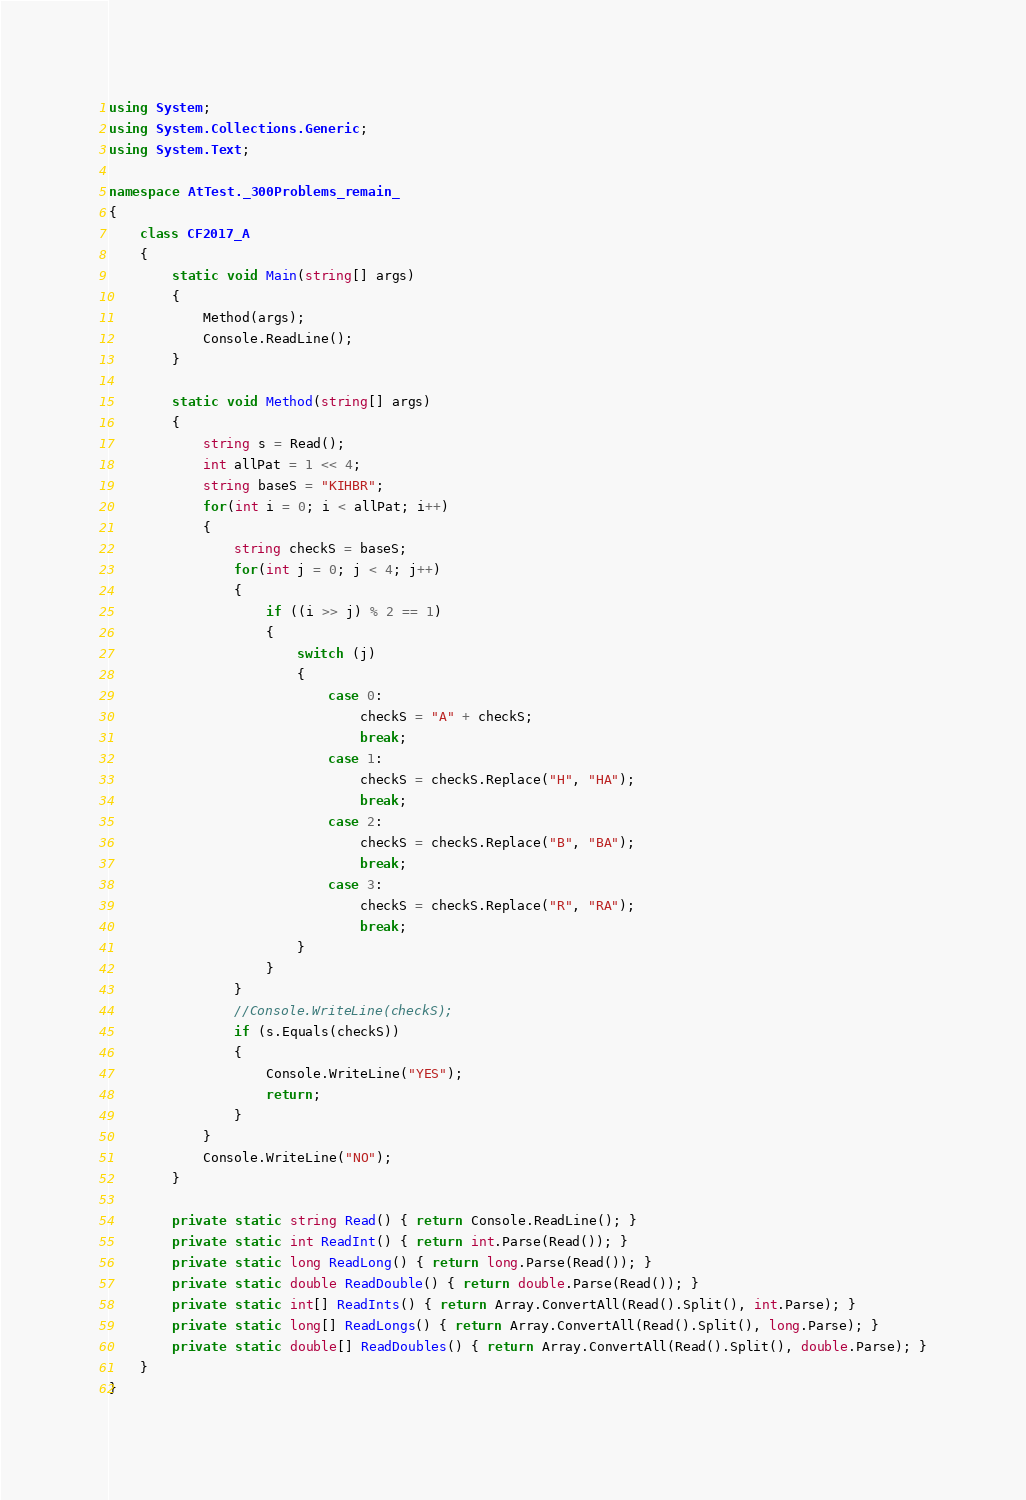<code> <loc_0><loc_0><loc_500><loc_500><_C#_>using System;
using System.Collections.Generic;
using System.Text;

namespace AtTest._300Problems_remain_
{
    class CF2017_A
    {
        static void Main(string[] args)
        {
            Method(args);
            Console.ReadLine();
        }

        static void Method(string[] args)
        {
            string s = Read();
            int allPat = 1 << 4;
            string baseS = "KIHBR";
            for(int i = 0; i < allPat; i++)
            {
                string checkS = baseS;
                for(int j = 0; j < 4; j++)
                {
                    if ((i >> j) % 2 == 1)
                    {
                        switch (j)
                        {
                            case 0:
                                checkS = "A" + checkS;
                                break;
                            case 1:
                                checkS = checkS.Replace("H", "HA");
                                break;
                            case 2:
                                checkS = checkS.Replace("B", "BA");
                                break;
                            case 3:
                                checkS = checkS.Replace("R", "RA");
                                break;
                        }
                    }
                }
                //Console.WriteLine(checkS);
                if (s.Equals(checkS))
                {
                    Console.WriteLine("YES");
                    return;
                }
            }
            Console.WriteLine("NO");
        }

        private static string Read() { return Console.ReadLine(); }
        private static int ReadInt() { return int.Parse(Read()); }
        private static long ReadLong() { return long.Parse(Read()); }
        private static double ReadDouble() { return double.Parse(Read()); }
        private static int[] ReadInts() { return Array.ConvertAll(Read().Split(), int.Parse); }
        private static long[] ReadLongs() { return Array.ConvertAll(Read().Split(), long.Parse); }
        private static double[] ReadDoubles() { return Array.ConvertAll(Read().Split(), double.Parse); }
    }
}
</code> 